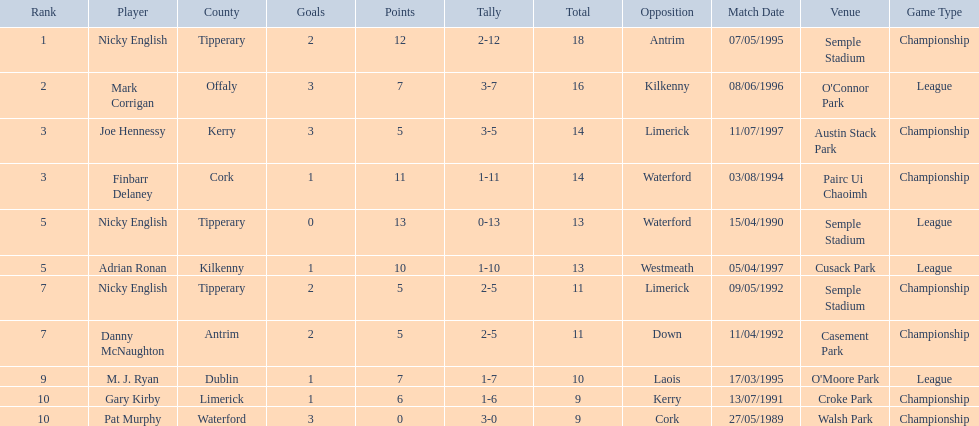Who was the highest-ranked player in a single match? Nicky English. 